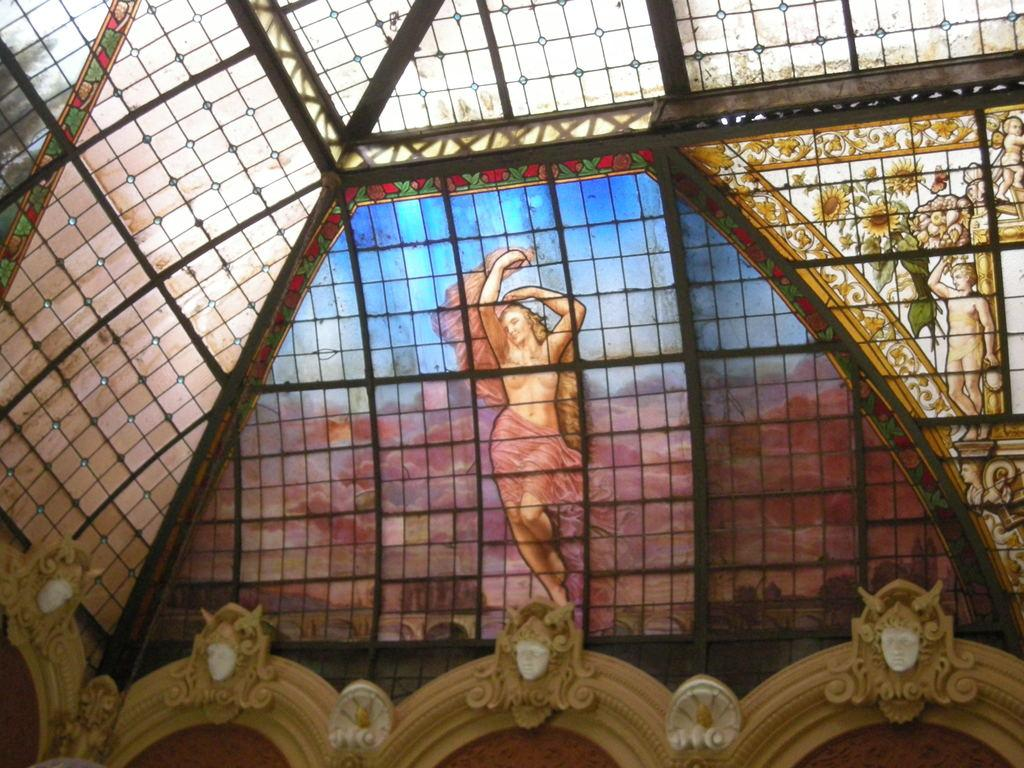What can be seen in the image that is used for cooking? There are grills in the image that are used for cooking. What type of architectural feature is present in the image? There are design glass walls in the image. What type of decorative objects are in the image? There are statues in the image. What can be seen growing on the design glass wall? Flowers are visible on the designed glass wall. What type of action is the stomach performing in the image? There is no stomach present in the image, so it is not possible to answer that question. 